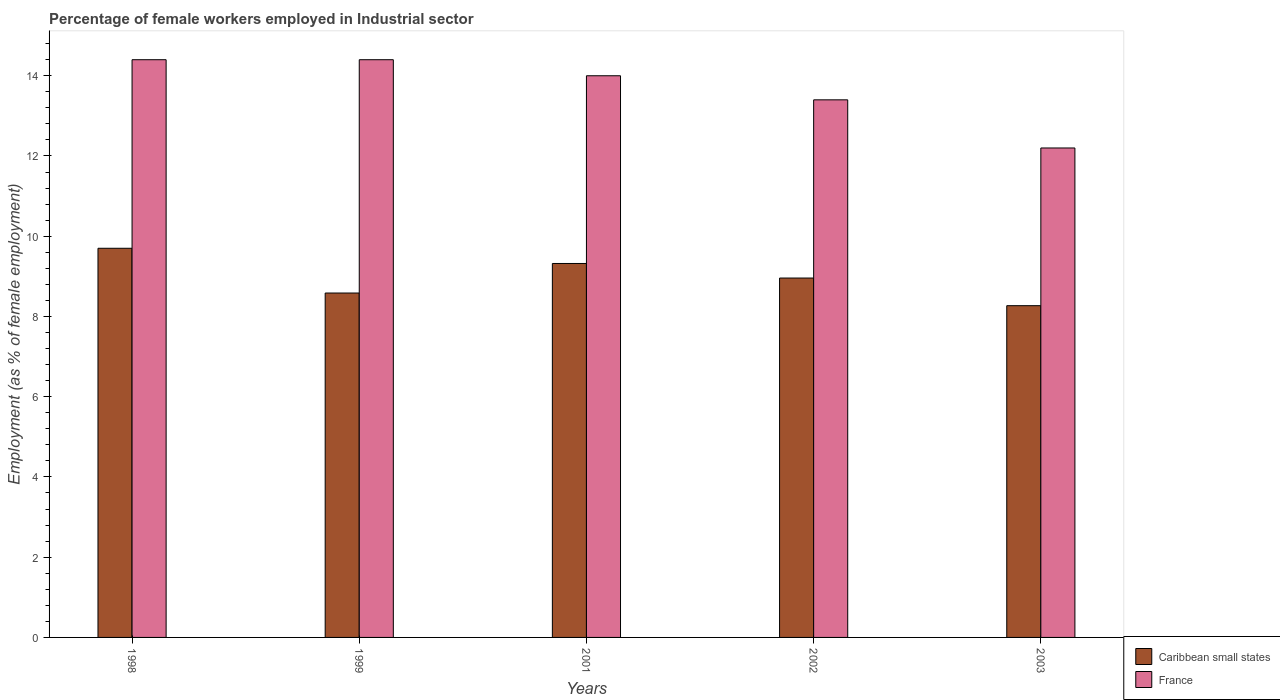Are the number of bars per tick equal to the number of legend labels?
Provide a succinct answer. Yes. Are the number of bars on each tick of the X-axis equal?
Your answer should be very brief. Yes. How many bars are there on the 5th tick from the right?
Your answer should be very brief. 2. What is the percentage of females employed in Industrial sector in Caribbean small states in 1998?
Make the answer very short. 9.7. Across all years, what is the maximum percentage of females employed in Industrial sector in Caribbean small states?
Your answer should be compact. 9.7. Across all years, what is the minimum percentage of females employed in Industrial sector in France?
Keep it short and to the point. 12.2. In which year was the percentage of females employed in Industrial sector in France maximum?
Keep it short and to the point. 1998. In which year was the percentage of females employed in Industrial sector in Caribbean small states minimum?
Your response must be concise. 2003. What is the total percentage of females employed in Industrial sector in France in the graph?
Your response must be concise. 68.4. What is the difference between the percentage of females employed in Industrial sector in France in 2002 and that in 2003?
Your answer should be compact. 1.2. What is the difference between the percentage of females employed in Industrial sector in France in 2002 and the percentage of females employed in Industrial sector in Caribbean small states in 1999?
Offer a very short reply. 4.82. What is the average percentage of females employed in Industrial sector in Caribbean small states per year?
Give a very brief answer. 8.97. In the year 2003, what is the difference between the percentage of females employed in Industrial sector in Caribbean small states and percentage of females employed in Industrial sector in France?
Ensure brevity in your answer.  -3.93. What is the ratio of the percentage of females employed in Industrial sector in Caribbean small states in 1998 to that in 2001?
Offer a terse response. 1.04. What is the difference between the highest and the second highest percentage of females employed in Industrial sector in Caribbean small states?
Offer a terse response. 0.38. What is the difference between the highest and the lowest percentage of females employed in Industrial sector in Caribbean small states?
Ensure brevity in your answer.  1.43. In how many years, is the percentage of females employed in Industrial sector in Caribbean small states greater than the average percentage of females employed in Industrial sector in Caribbean small states taken over all years?
Provide a succinct answer. 2. What does the 1st bar from the left in 1999 represents?
Give a very brief answer. Caribbean small states. What does the 1st bar from the right in 2002 represents?
Provide a short and direct response. France. How many bars are there?
Your answer should be very brief. 10. Are all the bars in the graph horizontal?
Offer a very short reply. No. How many years are there in the graph?
Provide a succinct answer. 5. Does the graph contain any zero values?
Give a very brief answer. No. Does the graph contain grids?
Offer a very short reply. No. Where does the legend appear in the graph?
Offer a terse response. Bottom right. How many legend labels are there?
Ensure brevity in your answer.  2. How are the legend labels stacked?
Your answer should be very brief. Vertical. What is the title of the graph?
Offer a terse response. Percentage of female workers employed in Industrial sector. Does "Small states" appear as one of the legend labels in the graph?
Make the answer very short. No. What is the label or title of the Y-axis?
Your answer should be compact. Employment (as % of female employment). What is the Employment (as % of female employment) of Caribbean small states in 1998?
Offer a terse response. 9.7. What is the Employment (as % of female employment) of France in 1998?
Offer a terse response. 14.4. What is the Employment (as % of female employment) of Caribbean small states in 1999?
Your response must be concise. 8.58. What is the Employment (as % of female employment) in France in 1999?
Offer a terse response. 14.4. What is the Employment (as % of female employment) of Caribbean small states in 2001?
Ensure brevity in your answer.  9.32. What is the Employment (as % of female employment) of France in 2001?
Your answer should be very brief. 14. What is the Employment (as % of female employment) in Caribbean small states in 2002?
Your answer should be very brief. 8.96. What is the Employment (as % of female employment) in France in 2002?
Give a very brief answer. 13.4. What is the Employment (as % of female employment) in Caribbean small states in 2003?
Provide a short and direct response. 8.27. What is the Employment (as % of female employment) in France in 2003?
Your answer should be compact. 12.2. Across all years, what is the maximum Employment (as % of female employment) of Caribbean small states?
Ensure brevity in your answer.  9.7. Across all years, what is the maximum Employment (as % of female employment) in France?
Provide a succinct answer. 14.4. Across all years, what is the minimum Employment (as % of female employment) in Caribbean small states?
Ensure brevity in your answer.  8.27. Across all years, what is the minimum Employment (as % of female employment) in France?
Make the answer very short. 12.2. What is the total Employment (as % of female employment) of Caribbean small states in the graph?
Keep it short and to the point. 44.83. What is the total Employment (as % of female employment) in France in the graph?
Make the answer very short. 68.4. What is the difference between the Employment (as % of female employment) in Caribbean small states in 1998 and that in 1999?
Ensure brevity in your answer.  1.12. What is the difference between the Employment (as % of female employment) of France in 1998 and that in 1999?
Keep it short and to the point. 0. What is the difference between the Employment (as % of female employment) of Caribbean small states in 1998 and that in 2001?
Provide a succinct answer. 0.38. What is the difference between the Employment (as % of female employment) of Caribbean small states in 1998 and that in 2002?
Ensure brevity in your answer.  0.74. What is the difference between the Employment (as % of female employment) in France in 1998 and that in 2002?
Your answer should be compact. 1. What is the difference between the Employment (as % of female employment) of Caribbean small states in 1998 and that in 2003?
Ensure brevity in your answer.  1.43. What is the difference between the Employment (as % of female employment) of Caribbean small states in 1999 and that in 2001?
Offer a terse response. -0.74. What is the difference between the Employment (as % of female employment) in France in 1999 and that in 2001?
Provide a short and direct response. 0.4. What is the difference between the Employment (as % of female employment) in Caribbean small states in 1999 and that in 2002?
Offer a very short reply. -0.37. What is the difference between the Employment (as % of female employment) in Caribbean small states in 1999 and that in 2003?
Your answer should be very brief. 0.32. What is the difference between the Employment (as % of female employment) in Caribbean small states in 2001 and that in 2002?
Your answer should be compact. 0.36. What is the difference between the Employment (as % of female employment) of France in 2001 and that in 2002?
Your response must be concise. 0.6. What is the difference between the Employment (as % of female employment) of Caribbean small states in 2001 and that in 2003?
Keep it short and to the point. 1.05. What is the difference between the Employment (as % of female employment) of France in 2001 and that in 2003?
Keep it short and to the point. 1.8. What is the difference between the Employment (as % of female employment) in Caribbean small states in 2002 and that in 2003?
Your response must be concise. 0.69. What is the difference between the Employment (as % of female employment) in Caribbean small states in 1998 and the Employment (as % of female employment) in France in 1999?
Make the answer very short. -4.7. What is the difference between the Employment (as % of female employment) in Caribbean small states in 1998 and the Employment (as % of female employment) in France in 2001?
Your answer should be very brief. -4.3. What is the difference between the Employment (as % of female employment) in Caribbean small states in 1998 and the Employment (as % of female employment) in France in 2002?
Your answer should be compact. -3.7. What is the difference between the Employment (as % of female employment) of Caribbean small states in 1998 and the Employment (as % of female employment) of France in 2003?
Offer a terse response. -2.5. What is the difference between the Employment (as % of female employment) of Caribbean small states in 1999 and the Employment (as % of female employment) of France in 2001?
Provide a succinct answer. -5.42. What is the difference between the Employment (as % of female employment) in Caribbean small states in 1999 and the Employment (as % of female employment) in France in 2002?
Give a very brief answer. -4.82. What is the difference between the Employment (as % of female employment) in Caribbean small states in 1999 and the Employment (as % of female employment) in France in 2003?
Offer a very short reply. -3.62. What is the difference between the Employment (as % of female employment) in Caribbean small states in 2001 and the Employment (as % of female employment) in France in 2002?
Provide a succinct answer. -4.08. What is the difference between the Employment (as % of female employment) of Caribbean small states in 2001 and the Employment (as % of female employment) of France in 2003?
Your response must be concise. -2.88. What is the difference between the Employment (as % of female employment) of Caribbean small states in 2002 and the Employment (as % of female employment) of France in 2003?
Give a very brief answer. -3.24. What is the average Employment (as % of female employment) in Caribbean small states per year?
Provide a succinct answer. 8.97. What is the average Employment (as % of female employment) of France per year?
Provide a short and direct response. 13.68. In the year 1998, what is the difference between the Employment (as % of female employment) in Caribbean small states and Employment (as % of female employment) in France?
Ensure brevity in your answer.  -4.7. In the year 1999, what is the difference between the Employment (as % of female employment) in Caribbean small states and Employment (as % of female employment) in France?
Provide a succinct answer. -5.82. In the year 2001, what is the difference between the Employment (as % of female employment) of Caribbean small states and Employment (as % of female employment) of France?
Make the answer very short. -4.68. In the year 2002, what is the difference between the Employment (as % of female employment) of Caribbean small states and Employment (as % of female employment) of France?
Your answer should be very brief. -4.44. In the year 2003, what is the difference between the Employment (as % of female employment) of Caribbean small states and Employment (as % of female employment) of France?
Your answer should be compact. -3.93. What is the ratio of the Employment (as % of female employment) in Caribbean small states in 1998 to that in 1999?
Provide a succinct answer. 1.13. What is the ratio of the Employment (as % of female employment) of France in 1998 to that in 1999?
Your answer should be very brief. 1. What is the ratio of the Employment (as % of female employment) of Caribbean small states in 1998 to that in 2001?
Provide a short and direct response. 1.04. What is the ratio of the Employment (as % of female employment) of France in 1998 to that in 2001?
Your answer should be very brief. 1.03. What is the ratio of the Employment (as % of female employment) of Caribbean small states in 1998 to that in 2002?
Offer a terse response. 1.08. What is the ratio of the Employment (as % of female employment) in France in 1998 to that in 2002?
Give a very brief answer. 1.07. What is the ratio of the Employment (as % of female employment) of Caribbean small states in 1998 to that in 2003?
Make the answer very short. 1.17. What is the ratio of the Employment (as % of female employment) in France in 1998 to that in 2003?
Keep it short and to the point. 1.18. What is the ratio of the Employment (as % of female employment) of Caribbean small states in 1999 to that in 2001?
Your response must be concise. 0.92. What is the ratio of the Employment (as % of female employment) of France in 1999 to that in 2001?
Give a very brief answer. 1.03. What is the ratio of the Employment (as % of female employment) of Caribbean small states in 1999 to that in 2002?
Your response must be concise. 0.96. What is the ratio of the Employment (as % of female employment) of France in 1999 to that in 2002?
Your answer should be compact. 1.07. What is the ratio of the Employment (as % of female employment) in Caribbean small states in 1999 to that in 2003?
Provide a short and direct response. 1.04. What is the ratio of the Employment (as % of female employment) of France in 1999 to that in 2003?
Offer a terse response. 1.18. What is the ratio of the Employment (as % of female employment) in Caribbean small states in 2001 to that in 2002?
Provide a succinct answer. 1.04. What is the ratio of the Employment (as % of female employment) in France in 2001 to that in 2002?
Make the answer very short. 1.04. What is the ratio of the Employment (as % of female employment) of Caribbean small states in 2001 to that in 2003?
Provide a succinct answer. 1.13. What is the ratio of the Employment (as % of female employment) in France in 2001 to that in 2003?
Ensure brevity in your answer.  1.15. What is the ratio of the Employment (as % of female employment) of France in 2002 to that in 2003?
Your answer should be very brief. 1.1. What is the difference between the highest and the second highest Employment (as % of female employment) of Caribbean small states?
Your answer should be compact. 0.38. What is the difference between the highest and the second highest Employment (as % of female employment) of France?
Ensure brevity in your answer.  0. What is the difference between the highest and the lowest Employment (as % of female employment) in Caribbean small states?
Provide a short and direct response. 1.43. 